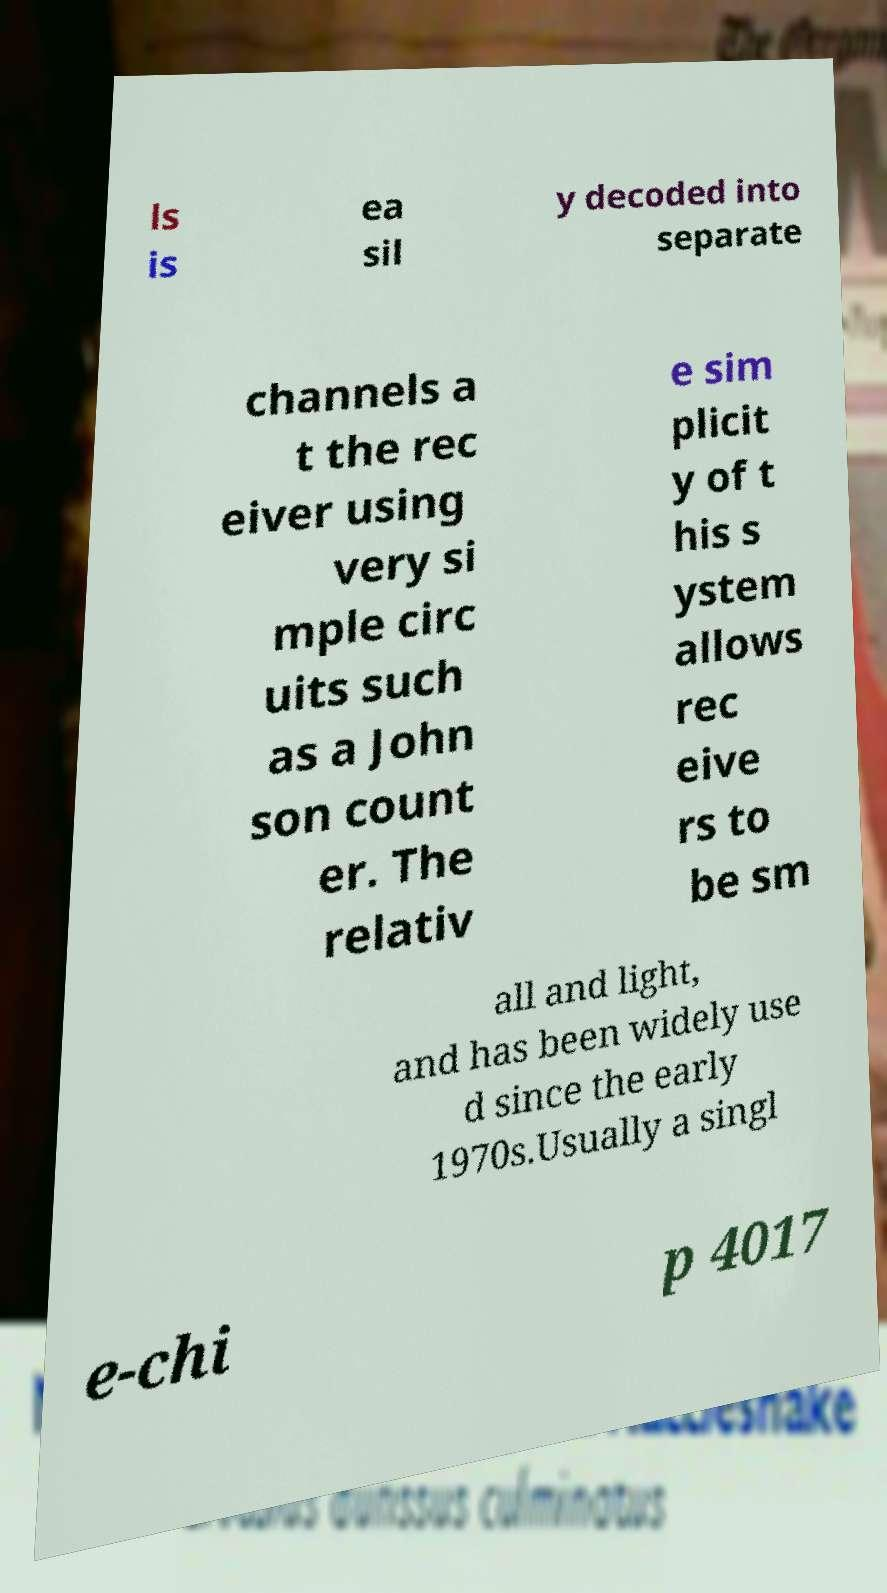Could you assist in decoding the text presented in this image and type it out clearly? ls is ea sil y decoded into separate channels a t the rec eiver using very si mple circ uits such as a John son count er. The relativ e sim plicit y of t his s ystem allows rec eive rs to be sm all and light, and has been widely use d since the early 1970s.Usually a singl e-chi p 4017 